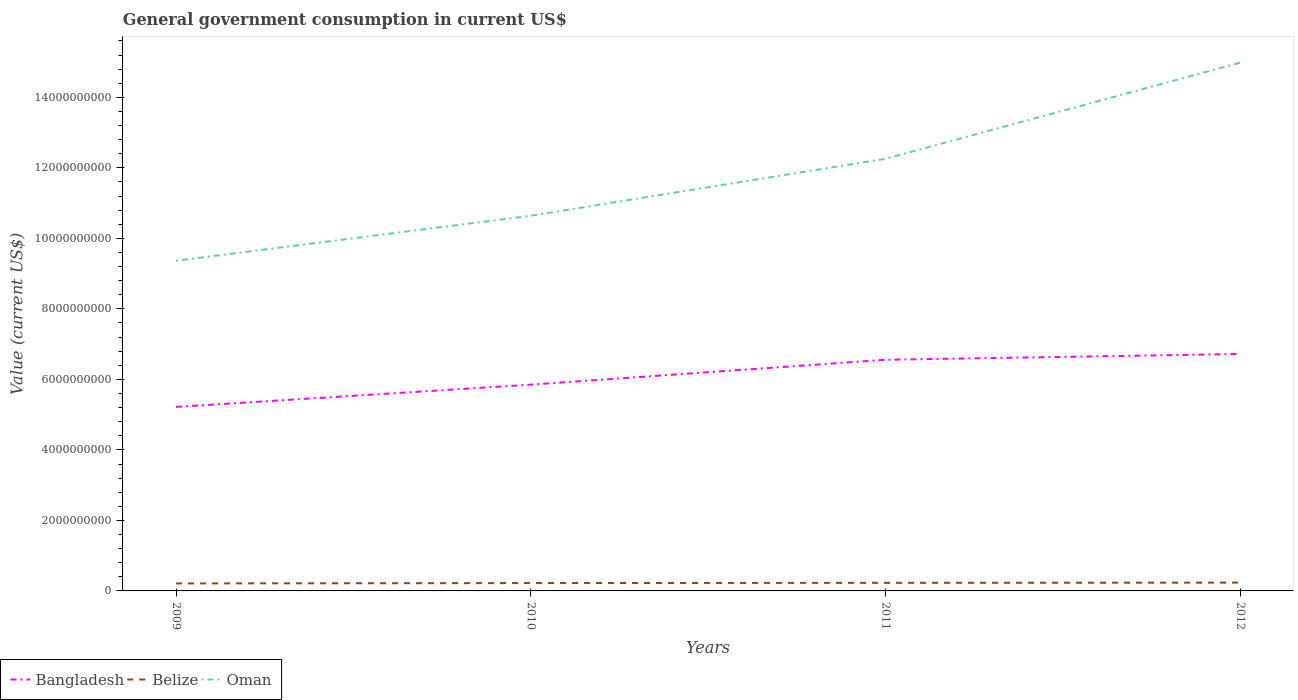How many different coloured lines are there?
Make the answer very short. 3. Is the number of lines equal to the number of legend labels?
Make the answer very short. Yes. Across all years, what is the maximum government conusmption in Bangladesh?
Offer a very short reply. 5.22e+09. What is the total government conusmption in Belize in the graph?
Your answer should be compact. -6.58e+06. What is the difference between the highest and the second highest government conusmption in Belize?
Offer a terse response. 2.31e+07. What is the difference between the highest and the lowest government conusmption in Oman?
Keep it short and to the point. 2. Is the government conusmption in Oman strictly greater than the government conusmption in Belize over the years?
Give a very brief answer. No. How many lines are there?
Your response must be concise. 3. How many years are there in the graph?
Your response must be concise. 4. What is the difference between two consecutive major ticks on the Y-axis?
Provide a short and direct response. 2.00e+09. Are the values on the major ticks of Y-axis written in scientific E-notation?
Your response must be concise. No. Does the graph contain any zero values?
Give a very brief answer. No. Does the graph contain grids?
Make the answer very short. No. Where does the legend appear in the graph?
Offer a very short reply. Bottom left. How are the legend labels stacked?
Provide a succinct answer. Horizontal. What is the title of the graph?
Keep it short and to the point. General government consumption in current US$. What is the label or title of the X-axis?
Your answer should be compact. Years. What is the label or title of the Y-axis?
Keep it short and to the point. Value (current US$). What is the Value (current US$) of Bangladesh in 2009?
Give a very brief answer. 5.22e+09. What is the Value (current US$) in Belize in 2009?
Offer a very short reply. 2.13e+08. What is the Value (current US$) in Oman in 2009?
Make the answer very short. 9.37e+09. What is the Value (current US$) in Bangladesh in 2010?
Provide a succinct answer. 5.85e+09. What is the Value (current US$) of Belize in 2010?
Offer a terse response. 2.23e+08. What is the Value (current US$) of Oman in 2010?
Your response must be concise. 1.06e+1. What is the Value (current US$) of Bangladesh in 2011?
Provide a succinct answer. 6.56e+09. What is the Value (current US$) in Belize in 2011?
Your response must be concise. 2.29e+08. What is the Value (current US$) of Oman in 2011?
Your response must be concise. 1.23e+1. What is the Value (current US$) in Bangladesh in 2012?
Provide a succinct answer. 6.72e+09. What is the Value (current US$) in Belize in 2012?
Provide a short and direct response. 2.36e+08. What is the Value (current US$) of Oman in 2012?
Your answer should be compact. 1.50e+1. Across all years, what is the maximum Value (current US$) of Bangladesh?
Provide a short and direct response. 6.72e+09. Across all years, what is the maximum Value (current US$) of Belize?
Your response must be concise. 2.36e+08. Across all years, what is the maximum Value (current US$) of Oman?
Offer a very short reply. 1.50e+1. Across all years, what is the minimum Value (current US$) in Bangladesh?
Your response must be concise. 5.22e+09. Across all years, what is the minimum Value (current US$) in Belize?
Offer a very short reply. 2.13e+08. Across all years, what is the minimum Value (current US$) of Oman?
Provide a succinct answer. 9.37e+09. What is the total Value (current US$) of Bangladesh in the graph?
Provide a succinct answer. 2.43e+1. What is the total Value (current US$) of Belize in the graph?
Provide a succinct answer. 9.01e+08. What is the total Value (current US$) in Oman in the graph?
Ensure brevity in your answer.  4.73e+1. What is the difference between the Value (current US$) of Bangladesh in 2009 and that in 2010?
Your answer should be compact. -6.31e+08. What is the difference between the Value (current US$) in Belize in 2009 and that in 2010?
Provide a succinct answer. -1.02e+07. What is the difference between the Value (current US$) of Oman in 2009 and that in 2010?
Your answer should be compact. -1.28e+09. What is the difference between the Value (current US$) of Bangladesh in 2009 and that in 2011?
Keep it short and to the point. -1.34e+09. What is the difference between the Value (current US$) of Belize in 2009 and that in 2011?
Your answer should be very brief. -1.68e+07. What is the difference between the Value (current US$) in Oman in 2009 and that in 2011?
Your response must be concise. -2.89e+09. What is the difference between the Value (current US$) of Bangladesh in 2009 and that in 2012?
Your answer should be compact. -1.50e+09. What is the difference between the Value (current US$) of Belize in 2009 and that in 2012?
Offer a very short reply. -2.31e+07. What is the difference between the Value (current US$) of Oman in 2009 and that in 2012?
Offer a terse response. -5.62e+09. What is the difference between the Value (current US$) of Bangladesh in 2010 and that in 2011?
Offer a terse response. -7.06e+08. What is the difference between the Value (current US$) of Belize in 2010 and that in 2011?
Offer a very short reply. -6.58e+06. What is the difference between the Value (current US$) in Oman in 2010 and that in 2011?
Ensure brevity in your answer.  -1.62e+09. What is the difference between the Value (current US$) of Bangladesh in 2010 and that in 2012?
Offer a terse response. -8.69e+08. What is the difference between the Value (current US$) of Belize in 2010 and that in 2012?
Give a very brief answer. -1.30e+07. What is the difference between the Value (current US$) in Oman in 2010 and that in 2012?
Offer a very short reply. -4.34e+09. What is the difference between the Value (current US$) in Bangladesh in 2011 and that in 2012?
Your answer should be very brief. -1.63e+08. What is the difference between the Value (current US$) of Belize in 2011 and that in 2012?
Offer a terse response. -6.40e+06. What is the difference between the Value (current US$) of Oman in 2011 and that in 2012?
Give a very brief answer. -2.73e+09. What is the difference between the Value (current US$) of Bangladesh in 2009 and the Value (current US$) of Belize in 2010?
Your answer should be compact. 5.00e+09. What is the difference between the Value (current US$) in Bangladesh in 2009 and the Value (current US$) in Oman in 2010?
Your answer should be compact. -5.42e+09. What is the difference between the Value (current US$) of Belize in 2009 and the Value (current US$) of Oman in 2010?
Provide a succinct answer. -1.04e+1. What is the difference between the Value (current US$) in Bangladesh in 2009 and the Value (current US$) in Belize in 2011?
Your answer should be compact. 4.99e+09. What is the difference between the Value (current US$) in Bangladesh in 2009 and the Value (current US$) in Oman in 2011?
Ensure brevity in your answer.  -7.04e+09. What is the difference between the Value (current US$) of Belize in 2009 and the Value (current US$) of Oman in 2011?
Offer a terse response. -1.20e+1. What is the difference between the Value (current US$) of Bangladesh in 2009 and the Value (current US$) of Belize in 2012?
Your response must be concise. 4.98e+09. What is the difference between the Value (current US$) in Bangladesh in 2009 and the Value (current US$) in Oman in 2012?
Ensure brevity in your answer.  -9.77e+09. What is the difference between the Value (current US$) of Belize in 2009 and the Value (current US$) of Oman in 2012?
Ensure brevity in your answer.  -1.48e+1. What is the difference between the Value (current US$) in Bangladesh in 2010 and the Value (current US$) in Belize in 2011?
Make the answer very short. 5.62e+09. What is the difference between the Value (current US$) in Bangladesh in 2010 and the Value (current US$) in Oman in 2011?
Offer a terse response. -6.41e+09. What is the difference between the Value (current US$) of Belize in 2010 and the Value (current US$) of Oman in 2011?
Make the answer very short. -1.20e+1. What is the difference between the Value (current US$) of Bangladesh in 2010 and the Value (current US$) of Belize in 2012?
Make the answer very short. 5.62e+09. What is the difference between the Value (current US$) in Bangladesh in 2010 and the Value (current US$) in Oman in 2012?
Your response must be concise. -9.14e+09. What is the difference between the Value (current US$) of Belize in 2010 and the Value (current US$) of Oman in 2012?
Offer a very short reply. -1.48e+1. What is the difference between the Value (current US$) in Bangladesh in 2011 and the Value (current US$) in Belize in 2012?
Your answer should be compact. 6.32e+09. What is the difference between the Value (current US$) of Bangladesh in 2011 and the Value (current US$) of Oman in 2012?
Make the answer very short. -8.43e+09. What is the difference between the Value (current US$) in Belize in 2011 and the Value (current US$) in Oman in 2012?
Keep it short and to the point. -1.48e+1. What is the average Value (current US$) in Bangladesh per year?
Provide a short and direct response. 6.09e+09. What is the average Value (current US$) of Belize per year?
Provide a short and direct response. 2.25e+08. What is the average Value (current US$) in Oman per year?
Ensure brevity in your answer.  1.18e+1. In the year 2009, what is the difference between the Value (current US$) in Bangladesh and Value (current US$) in Belize?
Ensure brevity in your answer.  5.01e+09. In the year 2009, what is the difference between the Value (current US$) in Bangladesh and Value (current US$) in Oman?
Offer a terse response. -4.15e+09. In the year 2009, what is the difference between the Value (current US$) in Belize and Value (current US$) in Oman?
Offer a very short reply. -9.15e+09. In the year 2010, what is the difference between the Value (current US$) of Bangladesh and Value (current US$) of Belize?
Provide a short and direct response. 5.63e+09. In the year 2010, what is the difference between the Value (current US$) of Bangladesh and Value (current US$) of Oman?
Your answer should be compact. -4.79e+09. In the year 2010, what is the difference between the Value (current US$) of Belize and Value (current US$) of Oman?
Ensure brevity in your answer.  -1.04e+1. In the year 2011, what is the difference between the Value (current US$) of Bangladesh and Value (current US$) of Belize?
Offer a terse response. 6.33e+09. In the year 2011, what is the difference between the Value (current US$) of Bangladesh and Value (current US$) of Oman?
Give a very brief answer. -5.70e+09. In the year 2011, what is the difference between the Value (current US$) in Belize and Value (current US$) in Oman?
Keep it short and to the point. -1.20e+1. In the year 2012, what is the difference between the Value (current US$) in Bangladesh and Value (current US$) in Belize?
Your answer should be compact. 6.48e+09. In the year 2012, what is the difference between the Value (current US$) in Bangladesh and Value (current US$) in Oman?
Give a very brief answer. -8.27e+09. In the year 2012, what is the difference between the Value (current US$) in Belize and Value (current US$) in Oman?
Your answer should be very brief. -1.48e+1. What is the ratio of the Value (current US$) of Bangladesh in 2009 to that in 2010?
Provide a succinct answer. 0.89. What is the ratio of the Value (current US$) in Belize in 2009 to that in 2010?
Give a very brief answer. 0.95. What is the ratio of the Value (current US$) of Bangladesh in 2009 to that in 2011?
Offer a terse response. 0.8. What is the ratio of the Value (current US$) of Belize in 2009 to that in 2011?
Keep it short and to the point. 0.93. What is the ratio of the Value (current US$) of Oman in 2009 to that in 2011?
Make the answer very short. 0.76. What is the ratio of the Value (current US$) of Bangladesh in 2009 to that in 2012?
Offer a very short reply. 0.78. What is the ratio of the Value (current US$) in Belize in 2009 to that in 2012?
Make the answer very short. 0.9. What is the ratio of the Value (current US$) of Oman in 2009 to that in 2012?
Offer a terse response. 0.62. What is the ratio of the Value (current US$) in Bangladesh in 2010 to that in 2011?
Provide a short and direct response. 0.89. What is the ratio of the Value (current US$) in Belize in 2010 to that in 2011?
Make the answer very short. 0.97. What is the ratio of the Value (current US$) in Oman in 2010 to that in 2011?
Ensure brevity in your answer.  0.87. What is the ratio of the Value (current US$) in Bangladesh in 2010 to that in 2012?
Offer a very short reply. 0.87. What is the ratio of the Value (current US$) of Belize in 2010 to that in 2012?
Make the answer very short. 0.94. What is the ratio of the Value (current US$) in Oman in 2010 to that in 2012?
Provide a short and direct response. 0.71. What is the ratio of the Value (current US$) in Bangladesh in 2011 to that in 2012?
Keep it short and to the point. 0.98. What is the ratio of the Value (current US$) of Belize in 2011 to that in 2012?
Provide a succinct answer. 0.97. What is the ratio of the Value (current US$) of Oman in 2011 to that in 2012?
Your response must be concise. 0.82. What is the difference between the highest and the second highest Value (current US$) of Bangladesh?
Offer a very short reply. 1.63e+08. What is the difference between the highest and the second highest Value (current US$) of Belize?
Provide a short and direct response. 6.40e+06. What is the difference between the highest and the second highest Value (current US$) in Oman?
Ensure brevity in your answer.  2.73e+09. What is the difference between the highest and the lowest Value (current US$) of Bangladesh?
Offer a very short reply. 1.50e+09. What is the difference between the highest and the lowest Value (current US$) of Belize?
Offer a very short reply. 2.31e+07. What is the difference between the highest and the lowest Value (current US$) in Oman?
Offer a terse response. 5.62e+09. 